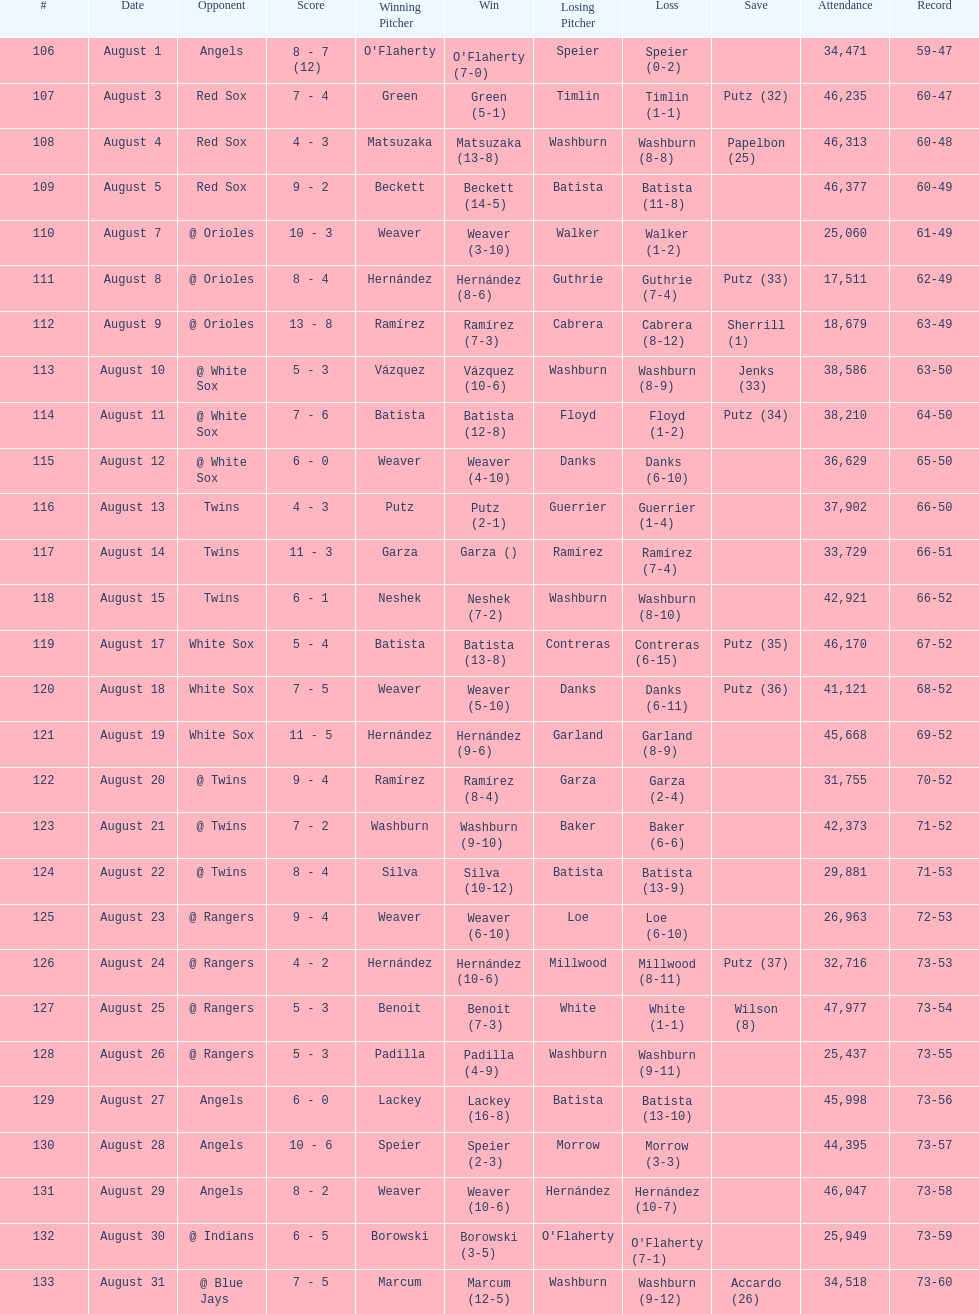How many losses during stretch? 7. 